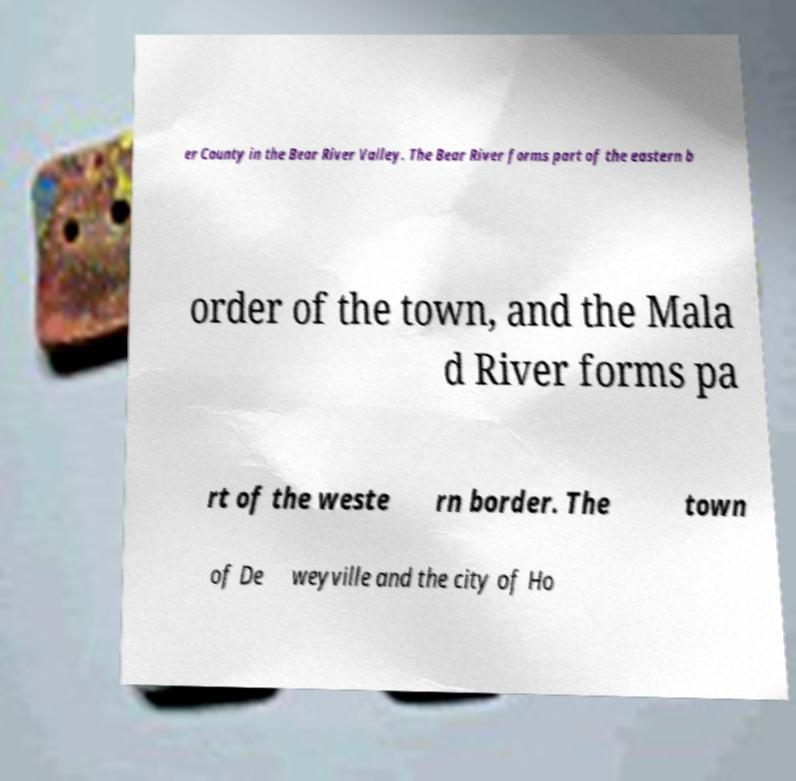There's text embedded in this image that I need extracted. Can you transcribe it verbatim? er County in the Bear River Valley. The Bear River forms part of the eastern b order of the town, and the Mala d River forms pa rt of the weste rn border. The town of De weyville and the city of Ho 